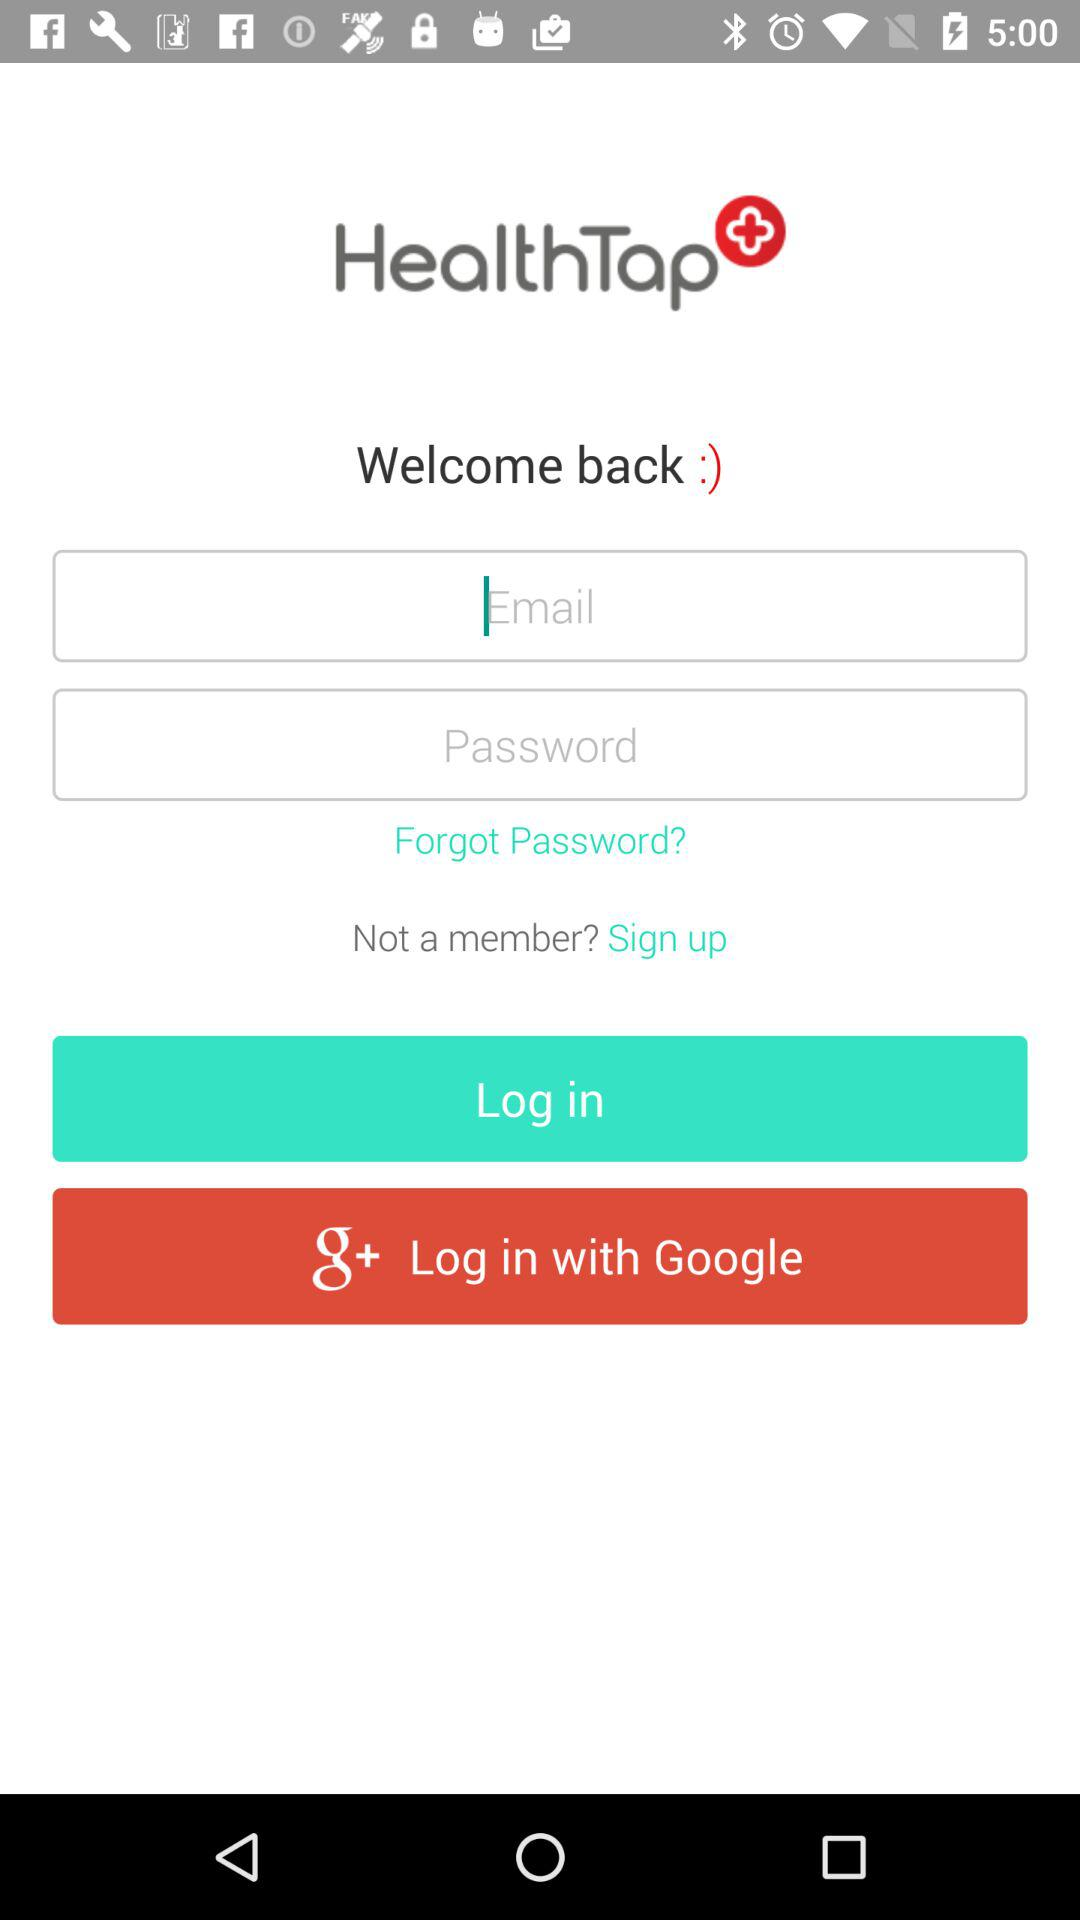What is the application name? The application name is "HealthTap+". 